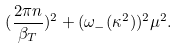Convert formula to latex. <formula><loc_0><loc_0><loc_500><loc_500>( \frac { 2 \pi n } { \beta _ { T } } ) ^ { 2 } + ( \omega _ { - } ( \kappa ^ { 2 } ) ) ^ { 2 } \mu ^ { 2 } .</formula> 